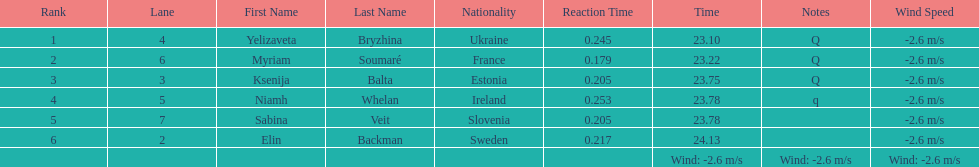Who is the first ranking player? Yelizaveta Bryzhina. 